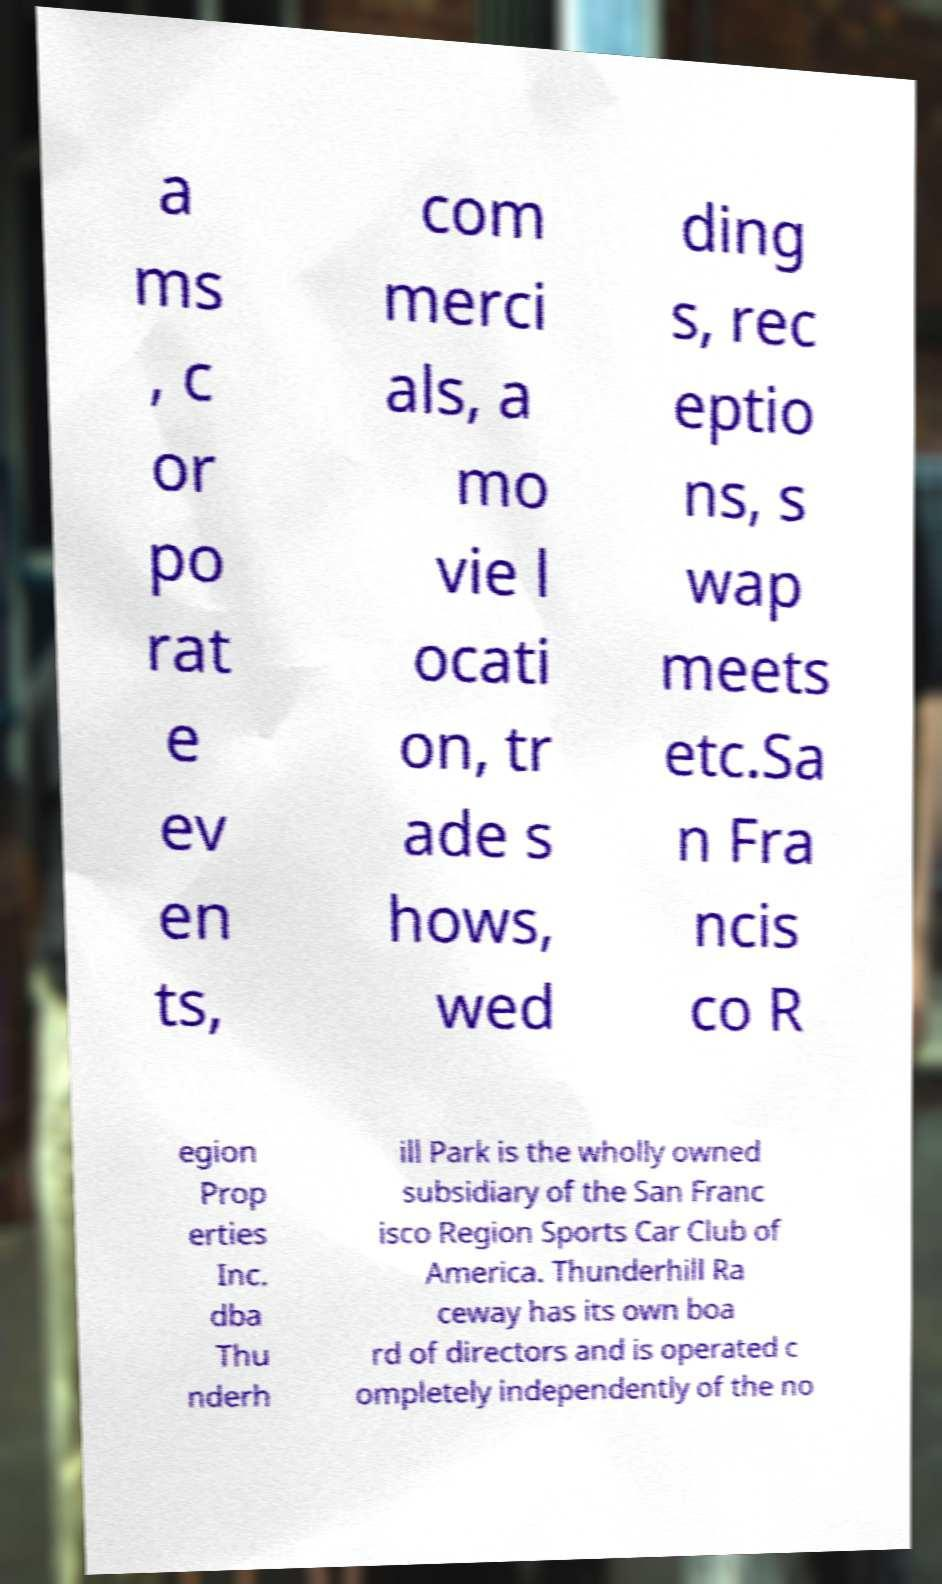Please identify and transcribe the text found in this image. a ms , c or po rat e ev en ts, com merci als, a mo vie l ocati on, tr ade s hows, wed ding s, rec eptio ns, s wap meets etc.Sa n Fra ncis co R egion Prop erties Inc. dba Thu nderh ill Park is the wholly owned subsidiary of the San Franc isco Region Sports Car Club of America. Thunderhill Ra ceway has its own boa rd of directors and is operated c ompletely independently of the no 